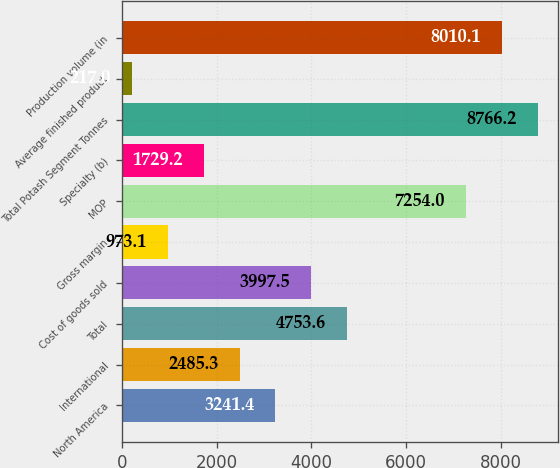Convert chart to OTSL. <chart><loc_0><loc_0><loc_500><loc_500><bar_chart><fcel>North America<fcel>International<fcel>Total<fcel>Cost of goods sold<fcel>Gross margin<fcel>MOP<fcel>Specialty (b)<fcel>Total Potash Segment Tonnes<fcel>Average finished product<fcel>Production volume (in<nl><fcel>3241.4<fcel>2485.3<fcel>4753.6<fcel>3997.5<fcel>973.1<fcel>7254<fcel>1729.2<fcel>8766.2<fcel>217<fcel>8010.1<nl></chart> 